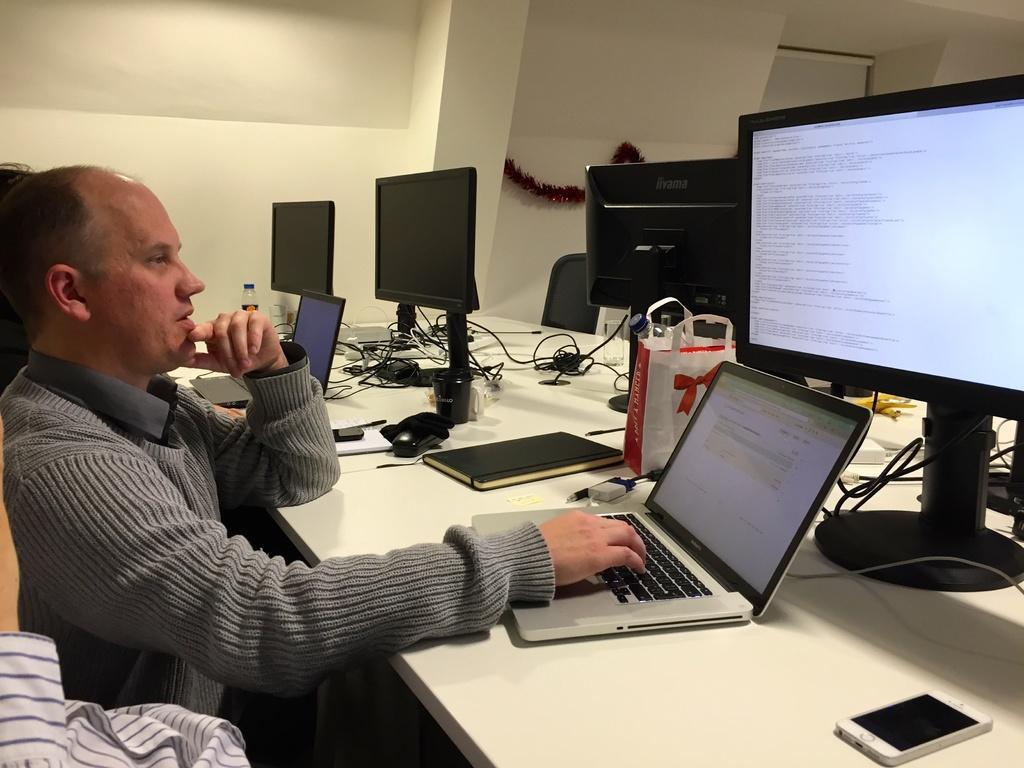Describe this image in one or two sentences. This picture shows three monitors and two laptops on the table and a man using the laptop 